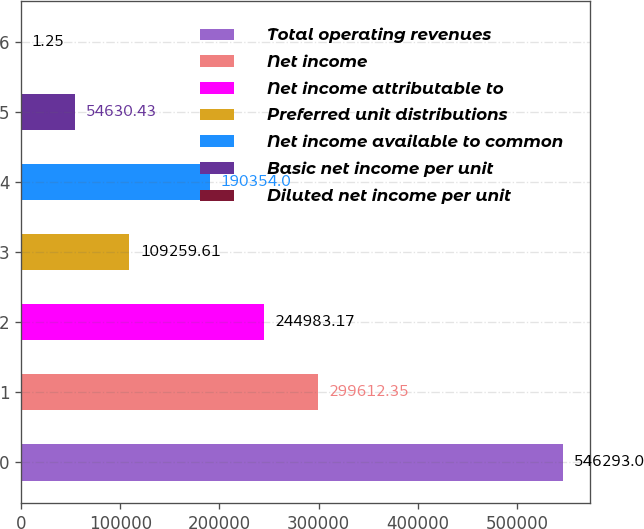<chart> <loc_0><loc_0><loc_500><loc_500><bar_chart><fcel>Total operating revenues<fcel>Net income<fcel>Net income attributable to<fcel>Preferred unit distributions<fcel>Net income available to common<fcel>Basic net income per unit<fcel>Diluted net income per unit<nl><fcel>546293<fcel>299612<fcel>244983<fcel>109260<fcel>190354<fcel>54630.4<fcel>1.25<nl></chart> 